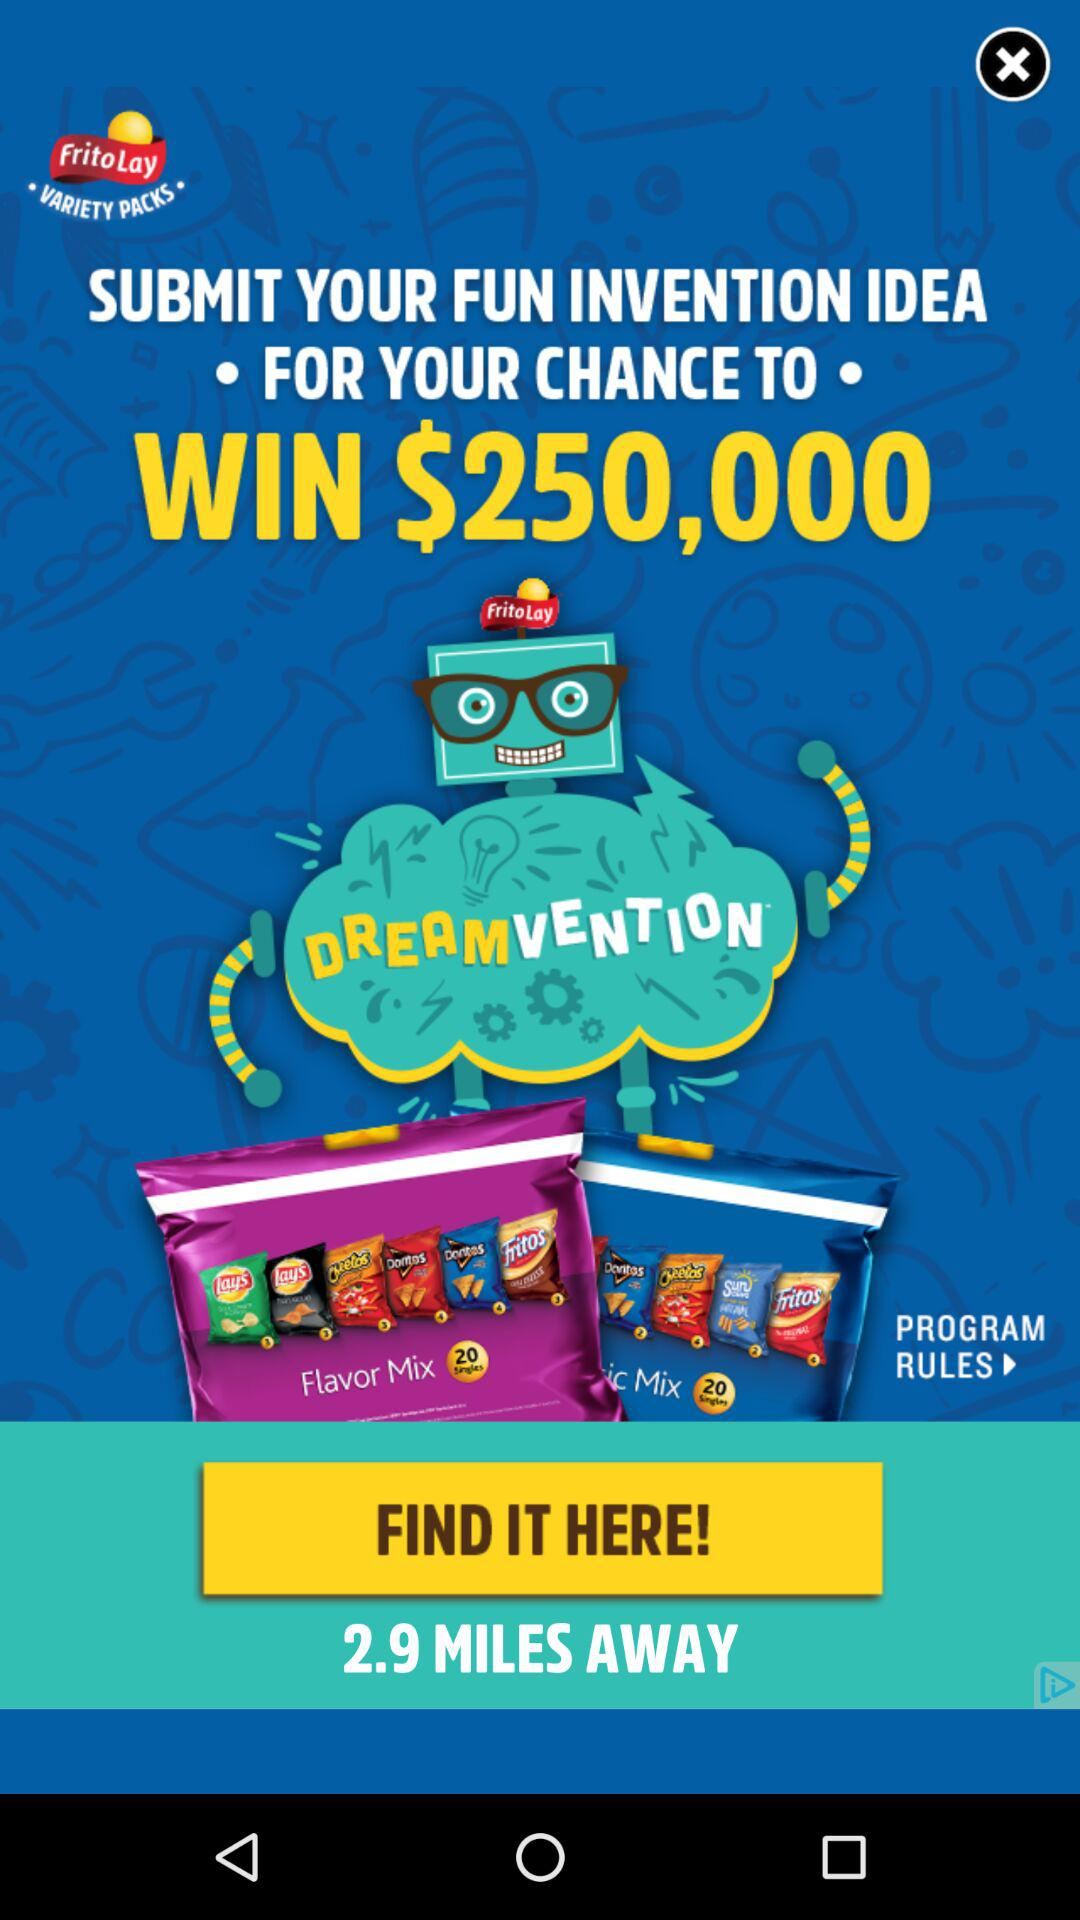How many dollars is the prize?
Answer the question using a single word or phrase. $250,000 